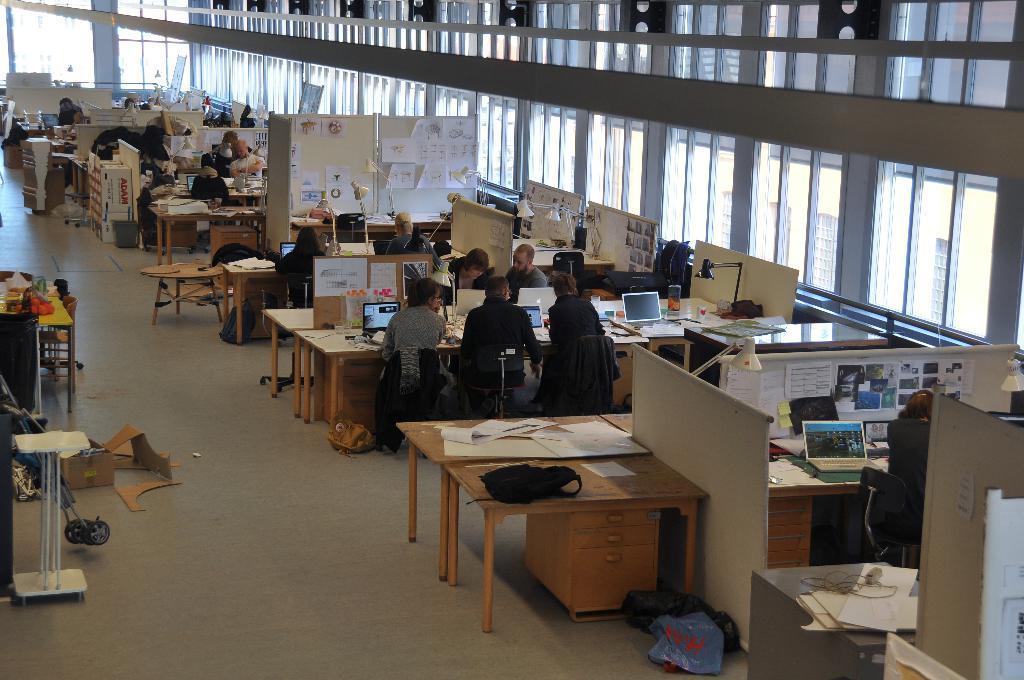Could you give a brief overview of what you see in this image? An indoor picture. we can able to see persons are sitting on chair. In-front of them there are tables. On this tables there are laptops and things. On this boards there are posters, papers and notes. On floor there is a cardboard box and plastic covers. On this table there are papers and bag. 